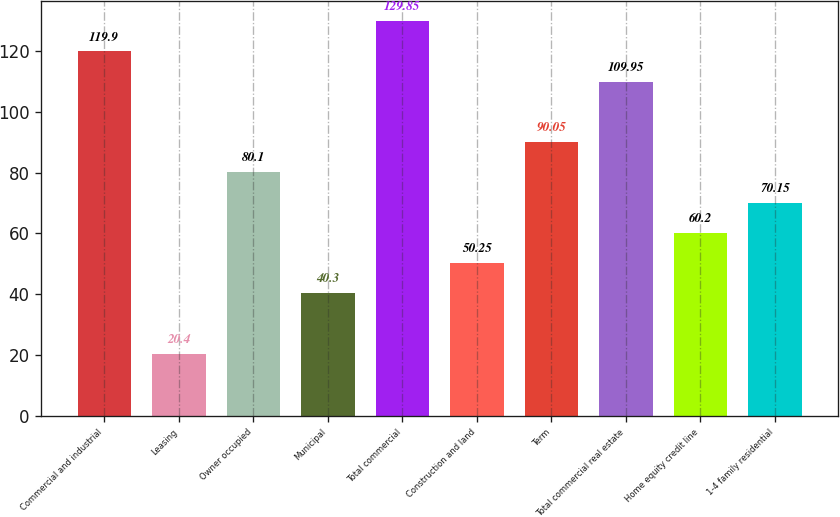Convert chart. <chart><loc_0><loc_0><loc_500><loc_500><bar_chart><fcel>Commercial and industrial<fcel>Leasing<fcel>Owner occupied<fcel>Municipal<fcel>Total commercial<fcel>Construction and land<fcel>Term<fcel>Total commercial real estate<fcel>Home equity credit line<fcel>1-4 family residential<nl><fcel>119.9<fcel>20.4<fcel>80.1<fcel>40.3<fcel>129.85<fcel>50.25<fcel>90.05<fcel>109.95<fcel>60.2<fcel>70.15<nl></chart> 